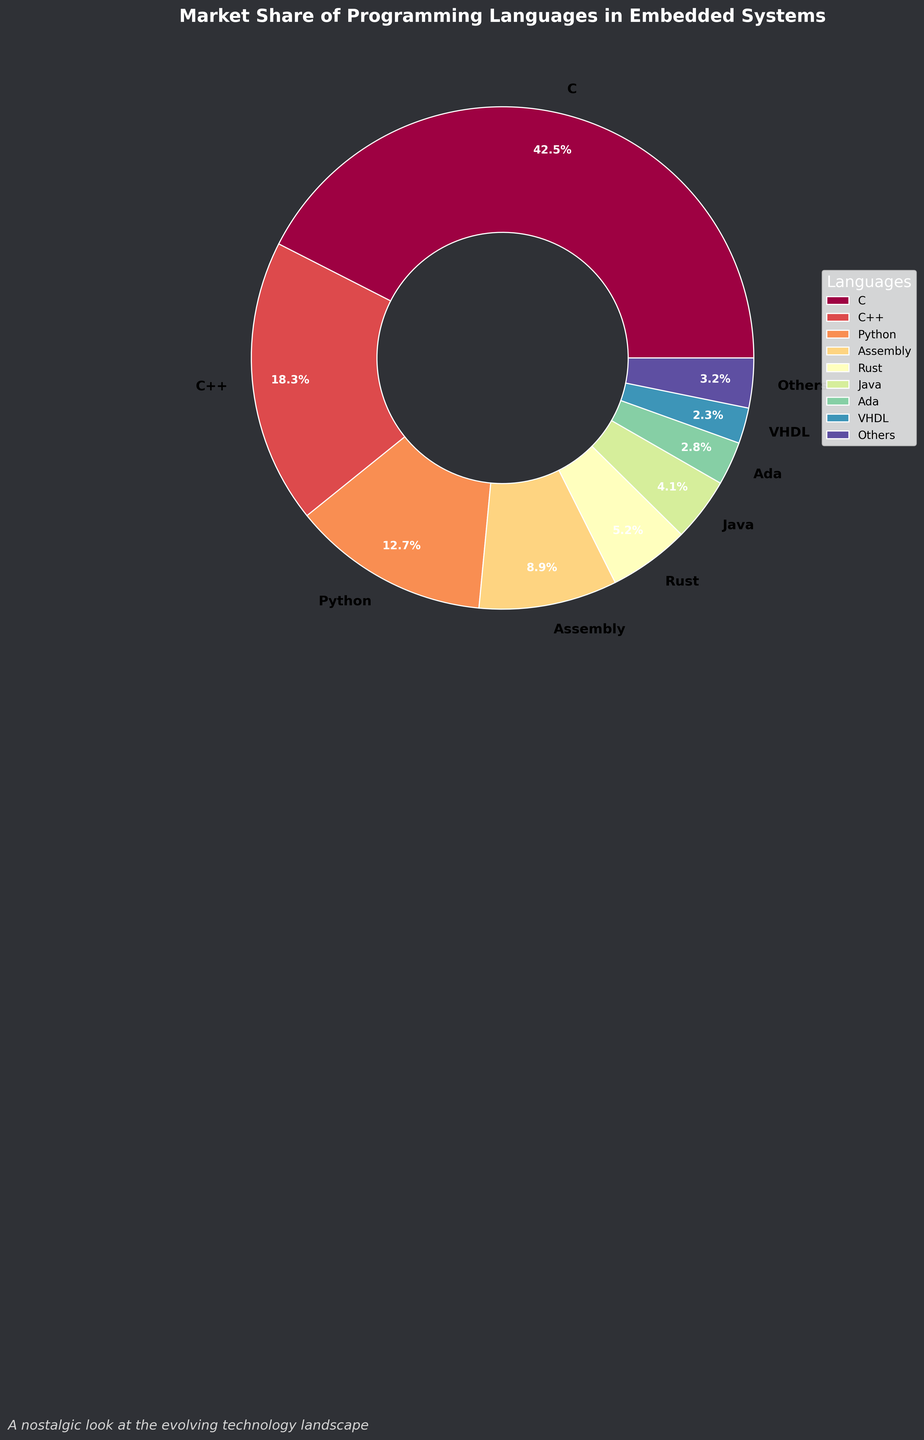How many languages have a market share greater than 10%? By observing the pie chart, identify which segments have percentages greater than 10% and count them.
Answer: 3 What is the combined market share of C and C++? Locate the percentages for C and C++ on the pie chart and add them together: 42.5% (C) + 18.3% (C++) = 60.8%
Answer: 60.8% Which language has the smallest market share displayed on the pie chart? Identify the segment with the smallest percentage by looking at the labels.
Answer: Forth How does the market share of Python compare to Java? Locate the segments for Python and Java and compare their percentages: 12.7% (Python) is higher than 4.1% (Java).
Answer: Python > Java Which languages are grouped under 'Others'? Identify the segments that are not labeled on the pie chart and total less than the threshold (e.g., 2.0%), then list them. This includes Lua (1.6%), JavaScript (1.2%), and Forth (0.4%).
Answer: Lua, JavaScript, Forth What is the total market share of all languages that are not categorized under 'Others'? Sum the percentages of all individually named segments: 42.5 (C) + 18.3 (C++) + 12.7 (Python) + 8.9 (Assembly) + 5.2 (Rust) + 4.1 (Java) + 2.8 (Ada) + 2.3 (VHDL) = 96.8%
Answer: 96.8% If the market share of Rust doubles next year, how would its new percentage compare to the current percentage of C++? Double Rust's current market share and then compare it to C++'s percentage: 5.2% * 2 = 10.4%; 10.4% is less than 18.3%.
Answer: Rust < C++ What is the average market share of top three languages? Average the percentages of the top three languages: (42.5% + 18.3% + 12.7%)/3 = 24.5%
Answer: 24.5% What's the difference in market share between Assembly and Rust? Find the market shares of Assembly and Rust, then subtract the smaller from the larger: 8.9% (Assembly) - 5.2% (Rust) = 3.7%
Answer: 3.7% What percentage of the market is taken by languages with a market share less than Ada? Identify languages with lower shares than Ada, then sum their percentages: Lua (1.6%), JavaScript (1.2%), Forth (0.4%) = 3.2%
Answer: 3.2% 